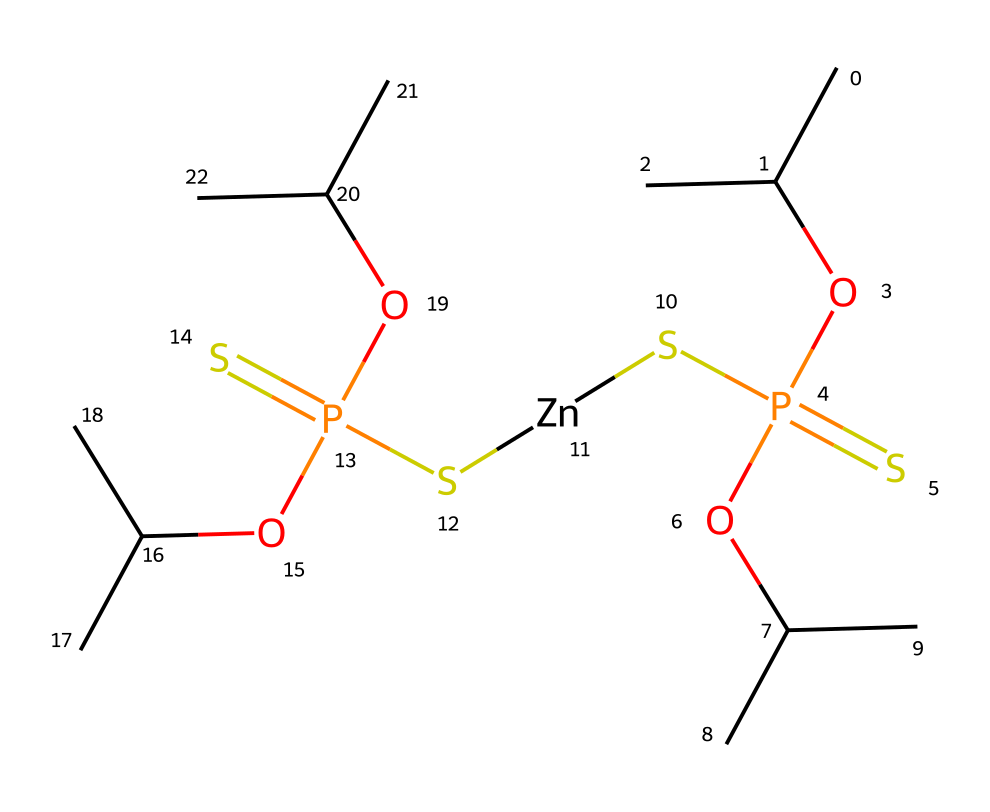What is the total number of phosphorus atoms in the structure? Counting the phosphorus atoms in the SMILES representation, there are two occurrences of the letter "P," each representing a phosphorus atom.
Answer: two How many sulfur atoms are present in the chemical structure? In the given SMILES, the letter "S" appears three times, indicating three sulfur atoms are present in the chemical structure.
Answer: three What is the metal cation present in this compound? The SMILES contains "[Zn]", which indicates the presence of a zinc cation in the chemical structure.
Answer: zinc What functional groups are featured in the chemical? Analyzing the structure revealed the presence of phosphate (P=O, -O) and sulfide (S-) functional groups, which are associated with the phosphorus and sulfur atoms.
Answer: phosphate, sulfide How many carbon atoms are in the structure? Counting the "C" symbols in the SMILES, there are seven carbon atoms present in total, taking into account both the side chains and the central structure.
Answer: seven What type of chemical is indicated by this structure? This chemical structure, with its metal complex, phosphorus, and sulfur groups, is characteristic of a hydraulic fluid additive, often used to enhance fluid properties.
Answer: hydraulic fluid additive What is the degree of saturation of the compound? The structure contains no rings or double bonds that would indicate unsaturation outside of the functional groups involved, suggesting that the connections are consistent with saturated features typical in hydraulic fluids.
Answer: saturated 